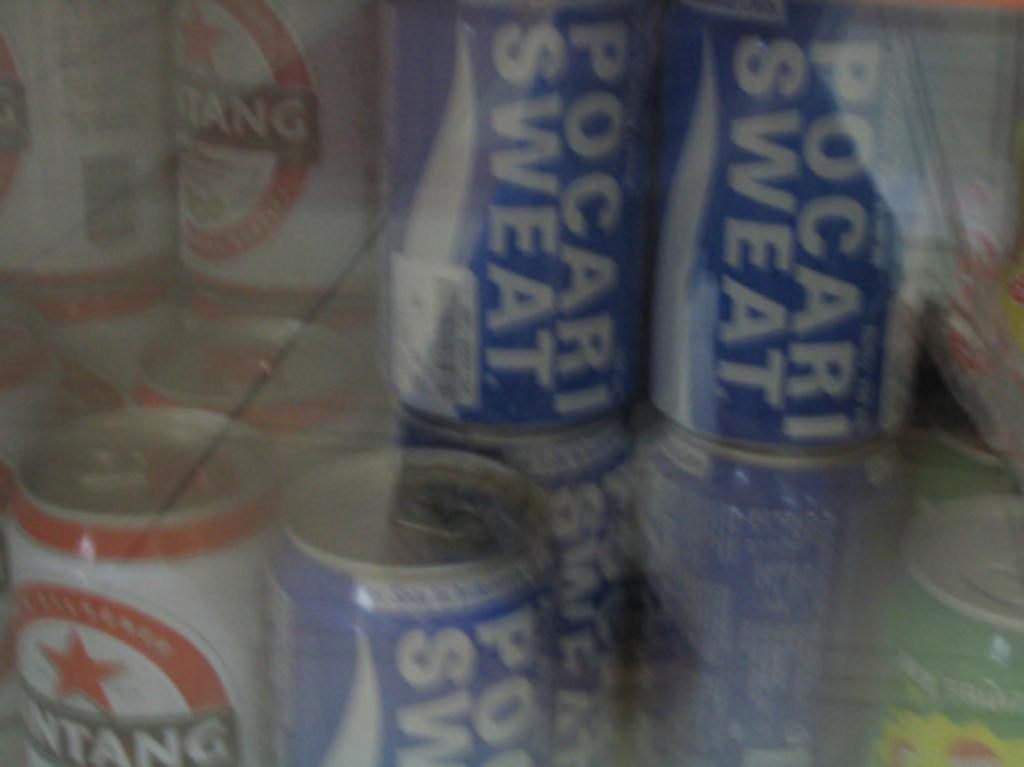<image>
Create a compact narrative representing the image presented. Several cans have a Pocari Sweat label on them. 